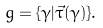Convert formula to latex. <formula><loc_0><loc_0><loc_500><loc_500>g = \{ \gamma | \vec { \tau } ( \gamma ) \} .</formula> 